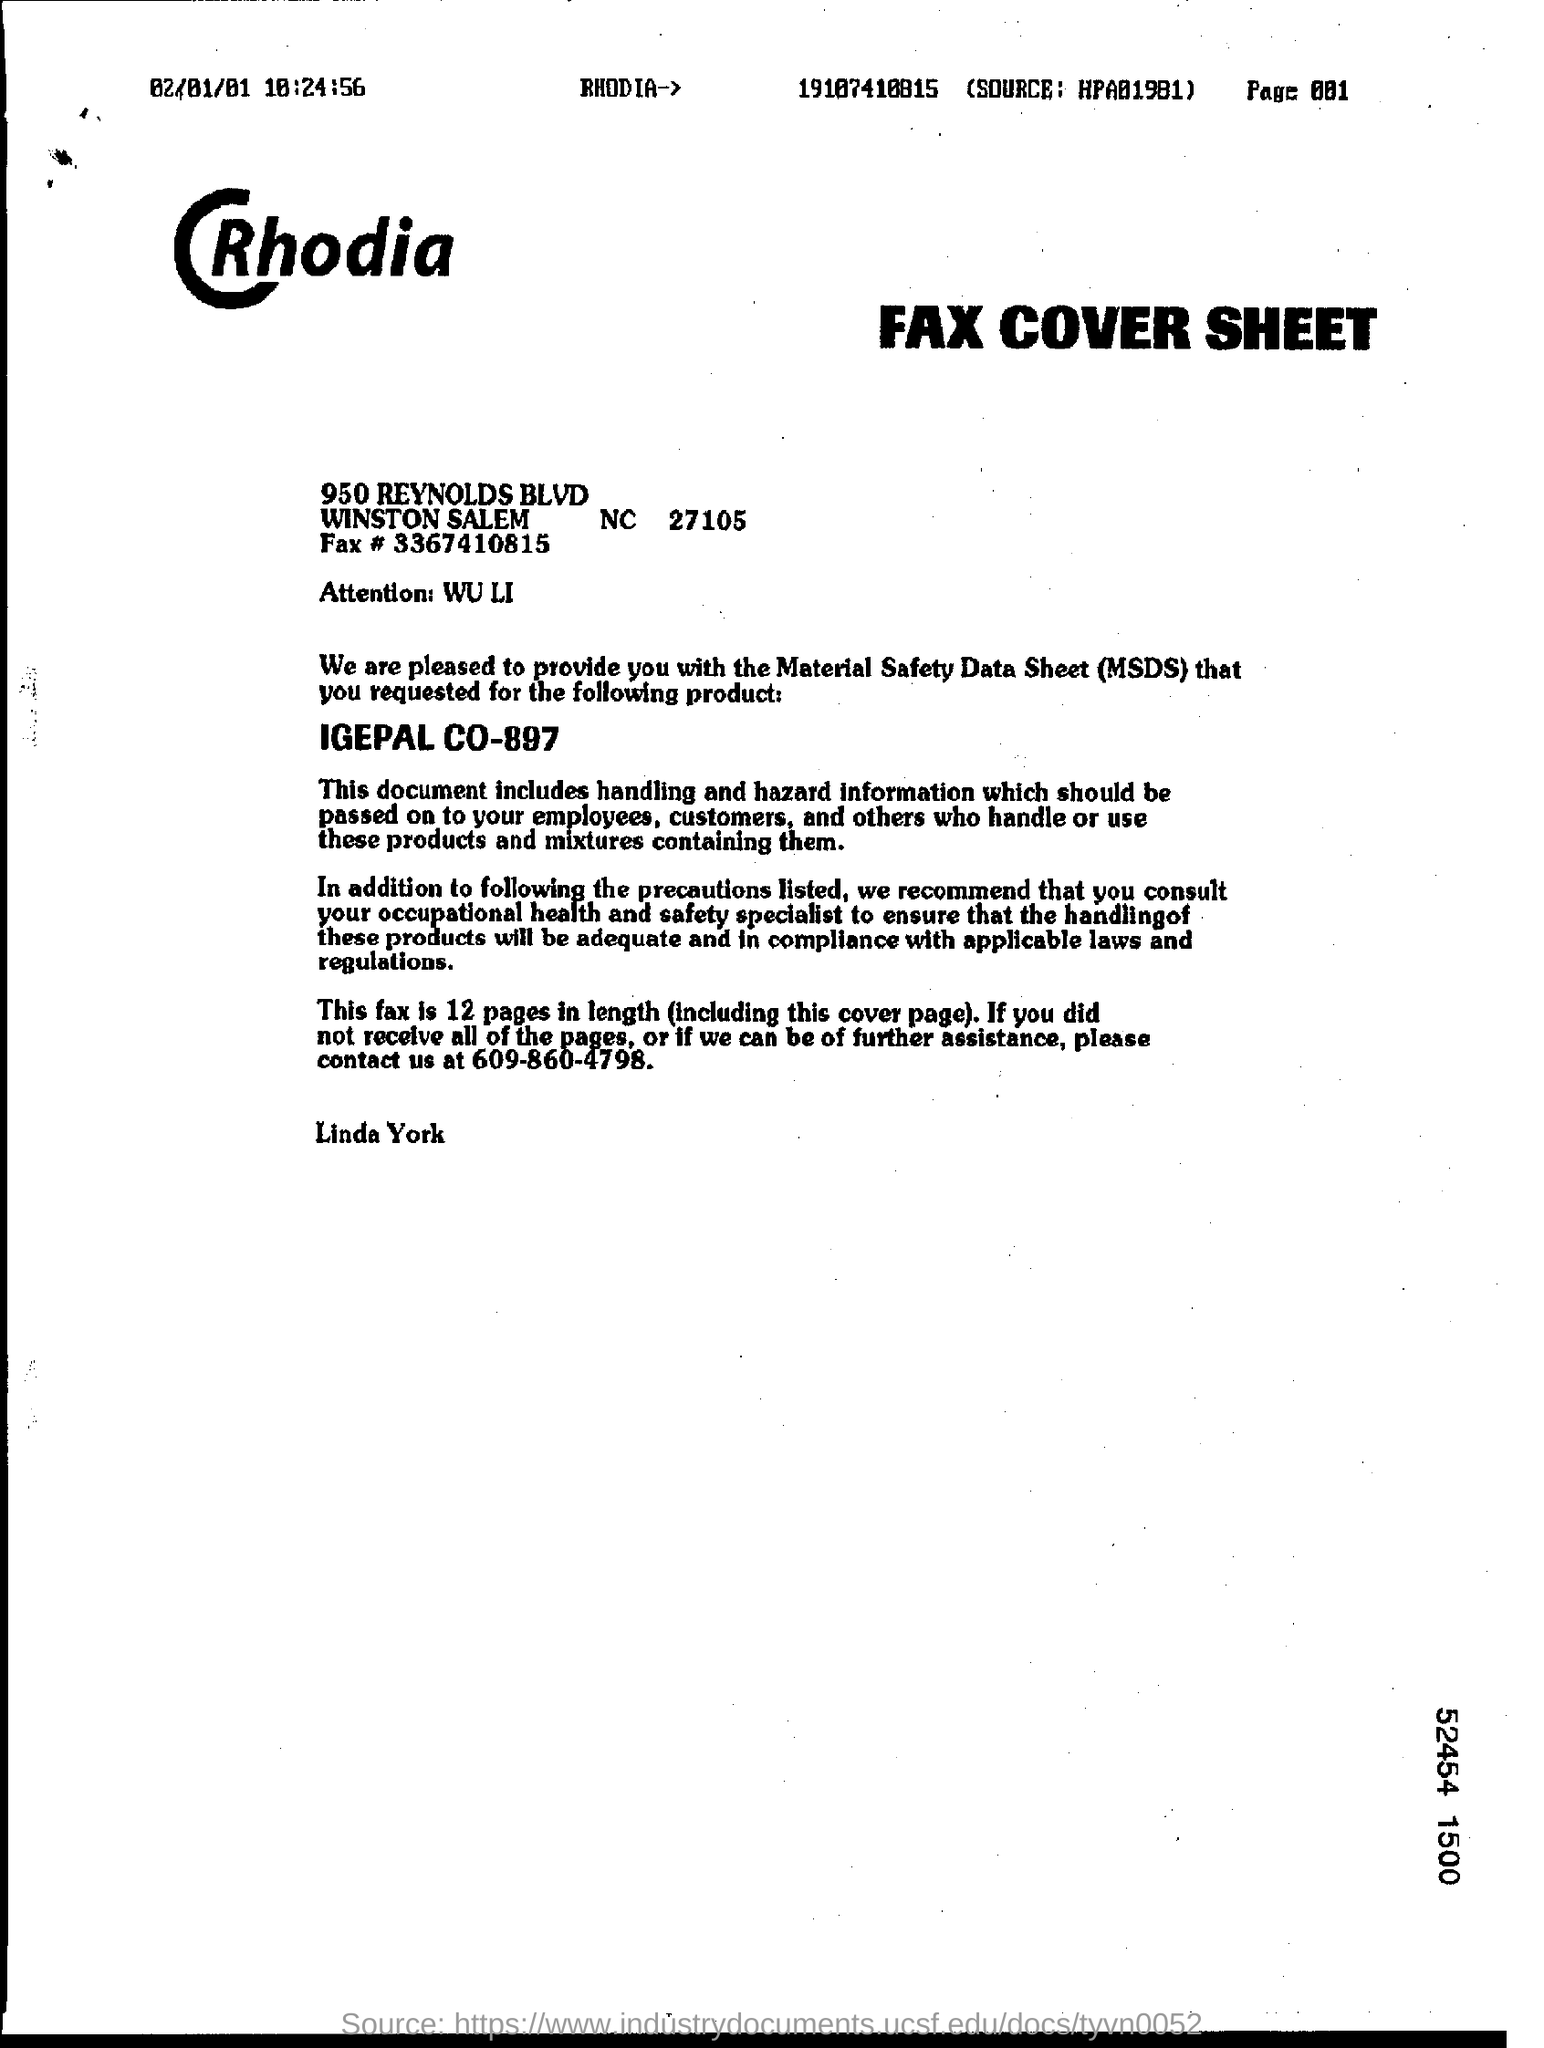Give some essential details in this illustration. The date mentioned in the page is February 1, 2001. The full form of MSDS is material safety data sheet. There are a total of 12 pages, including the cover page. The contact number provided for further assistance is 609-860-4798. 